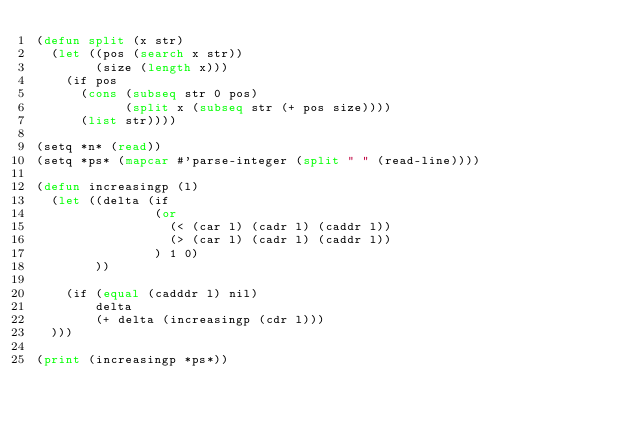<code> <loc_0><loc_0><loc_500><loc_500><_Lisp_>(defun split (x str)
  (let ((pos (search x str))
        (size (length x)))
    (if pos
      (cons (subseq str 0 pos)
            (split x (subseq str (+ pos size))))
      (list str))))

(setq *n* (read))
(setq *ps* (mapcar #'parse-integer (split " " (read-line))))

(defun increasingp (l)
  (let ((delta (if
                (or
                  (< (car l) (cadr l) (caddr l))
                  (> (car l) (cadr l) (caddr l))
                ) 1 0)
        ))
       
    (if (equal (cadddr l) nil)
        delta
        (+ delta (increasingp (cdr l)))
  )))

(print (increasingp *ps*))</code> 